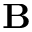<formula> <loc_0><loc_0><loc_500><loc_500>{ B }</formula> 